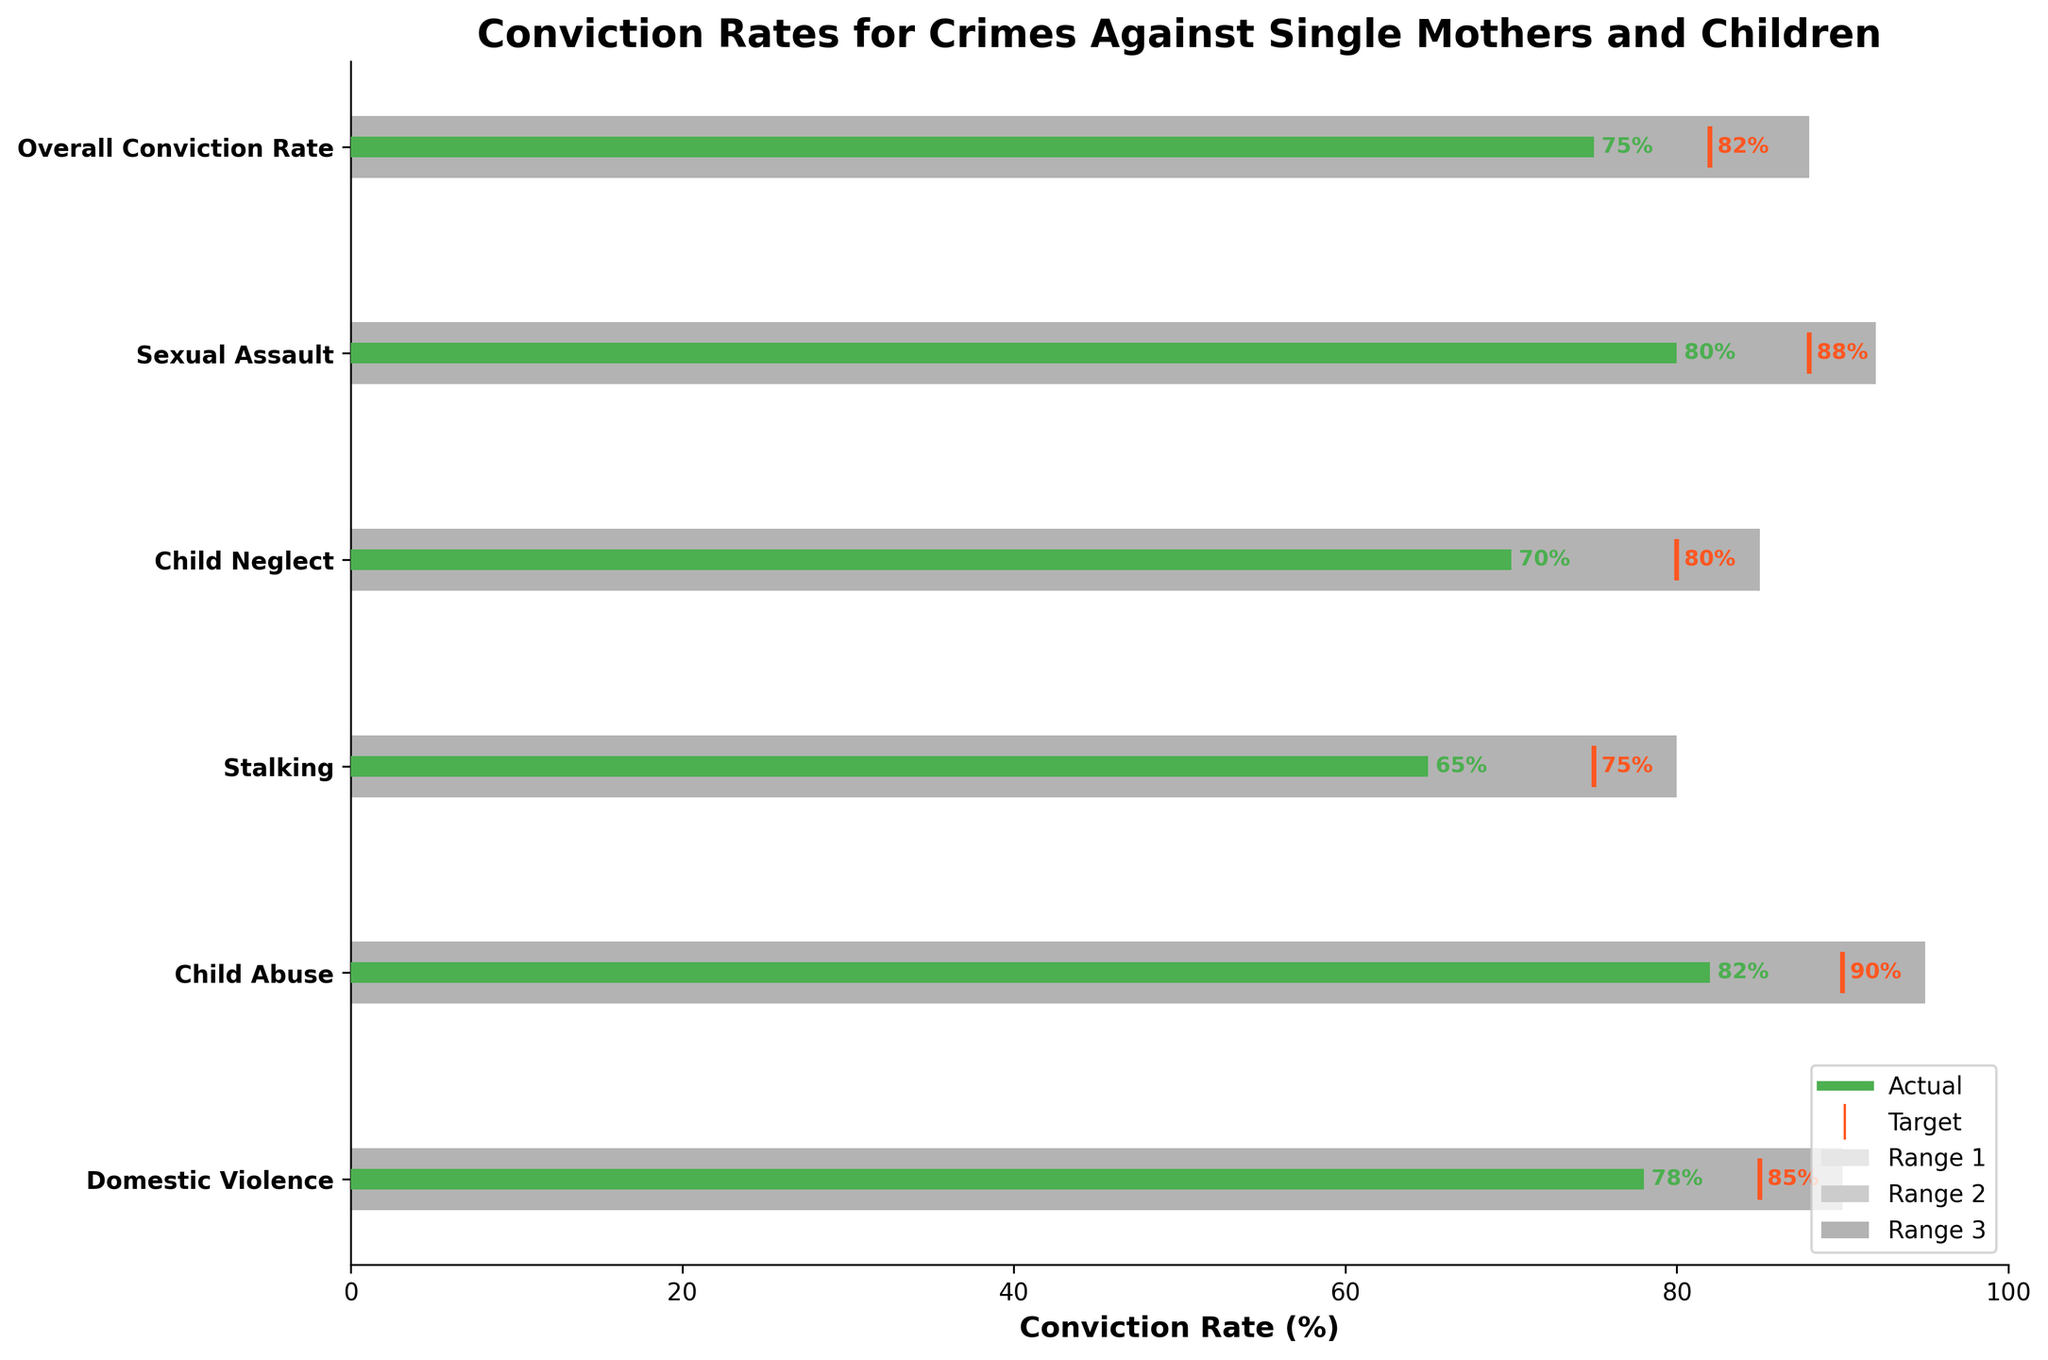What's the title of the chart? The title of the chart is located at the top center, and it reads: "Conviction Rates for Crimes Against Single Mothers and Children".
Answer: Conviction Rates for Crimes Against Single Mothers and Children What is the actual conviction rate for Child Abuse? The actual conviction rate for each category is shown by the green bar. For Child Abuse, the green bar shows a value of 82%.
Answer: 82% Which category has the highest target conviction rate? The target rates are represented by orange vertical lines. Among them, Child Abuse has the highest target at 90%.
Answer: Child Abuse What is the difference between the actual and target conviction rates for Domestic Violence? The actual conviction rate for Domestic Violence is 78%, and the target rate is 85%. The difference is 85% - 78% = 7%.
Answer: 7% How many categories have actual conviction rates below their targets? By comparing the green bars (actual) with orange lines (targets), we see Domestic Violence, Stalking, and Child Neglect have actual rates below target. This amounts to three categories.
Answer: 3 Which category falls within the third performance range for its actual conviction rate? The third range is generally the darkest shaded area (Range 3). Sexual Assault (actual 80%) falls into the third range (62-78%).
Answer: Sexual Assault What is the overall conviction rate compared to its target? The overall conviction rate is represented by a green bar at 75% and its target by an orange line at 82%, resulting in the actual rate being 7% below target.
Answer: 7% Which category has the smallest difference between actual and target conviction rates? By looking at the green (actual) and orange (target) values, Child Neglect has the smallest difference as its actual is 70% and target is 80%, resulting in a 10% difference.
Answer: Child Neglect What's the average actual conviction rate across all categories? The actual rates are 78, 82, 65, 70, 80, and 75. Sum these up to get 450, then divide by 6 (number of categories): 450 / 6 = 75%.
Answer: 75% How does the actual conviction rate of Stalking compare to the overall conviction rate? The actual conviction rate for Stalking is 65%, while the overall conviction rate is 75%. So, Stalking's rate is 10% lower than the overall rate.
Answer: 10% lower 